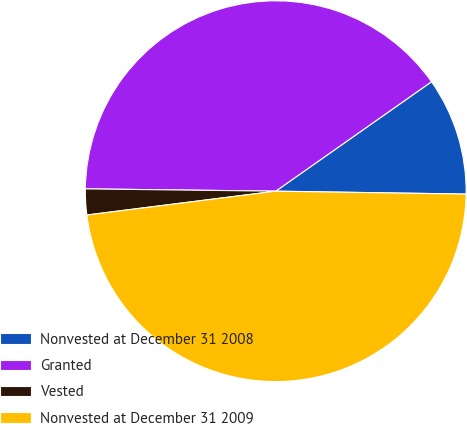Convert chart. <chart><loc_0><loc_0><loc_500><loc_500><pie_chart><fcel>Nonvested at December 31 2008<fcel>Granted<fcel>Vested<fcel>Nonvested at December 31 2009<nl><fcel>9.99%<fcel>40.06%<fcel>2.19%<fcel>47.76%<nl></chart> 